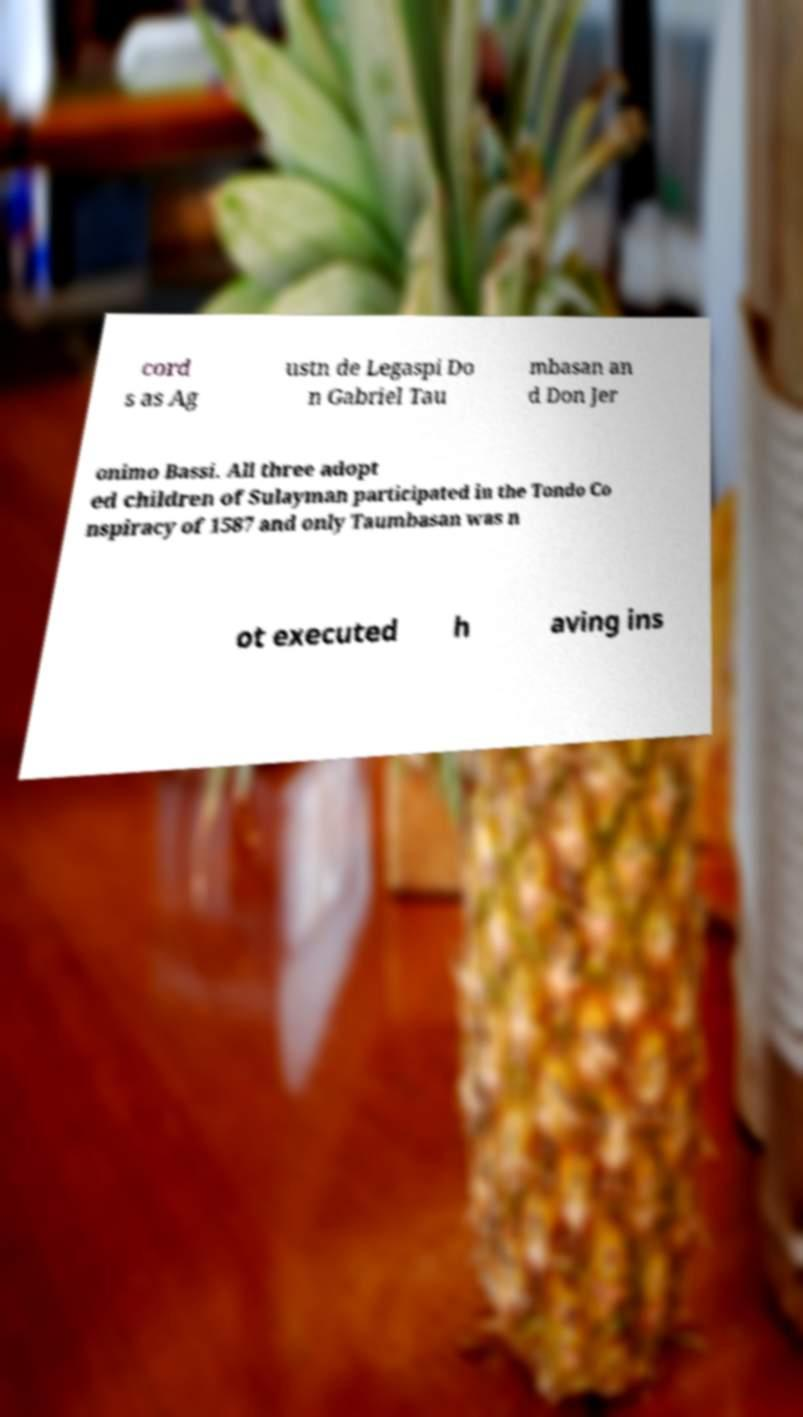Please read and relay the text visible in this image. What does it say? cord s as Ag ustn de Legaspi Do n Gabriel Tau mbasan an d Don Jer onimo Bassi. All three adopt ed children of Sulayman participated in the Tondo Co nspiracy of 1587 and only Taumbasan was n ot executed h aving ins 